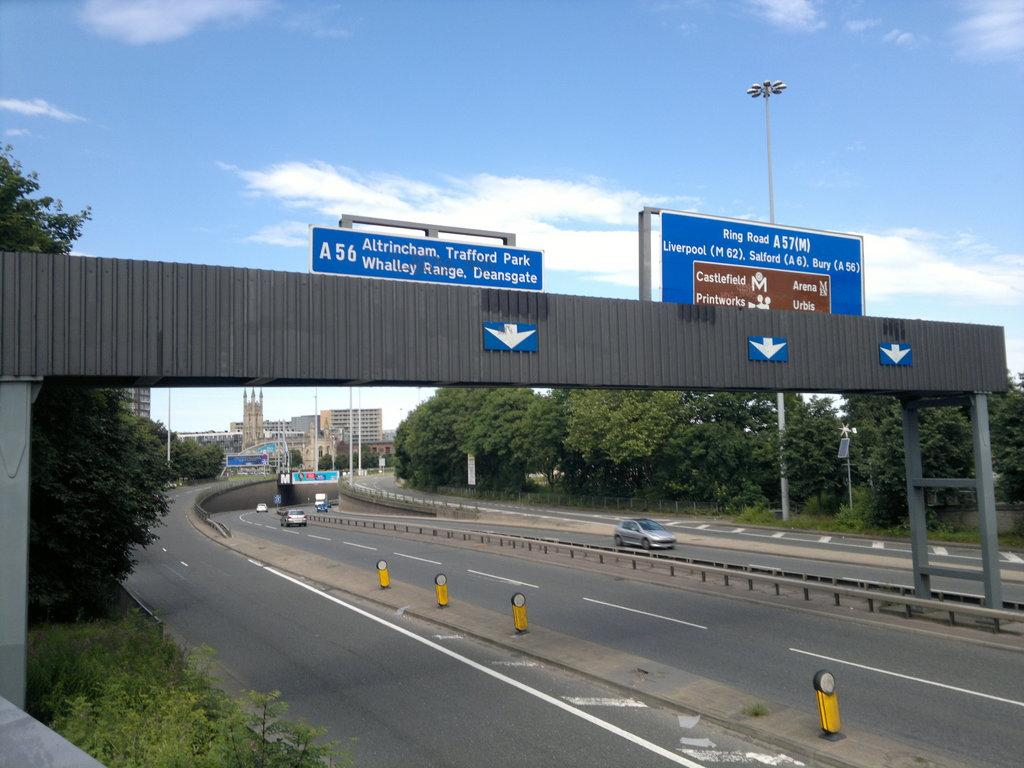<image>
Provide a brief description of the given image. A freeway where a large sign stretches above the lanes and says Altricham Trafford Park. 